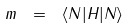Convert formula to latex. <formula><loc_0><loc_0><loc_500><loc_500>m \ = \ \langle N | H | N \rangle</formula> 